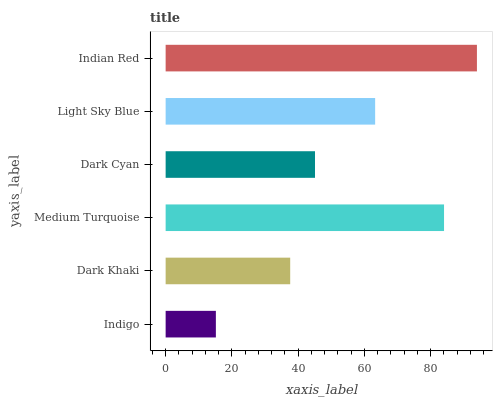Is Indigo the minimum?
Answer yes or no. Yes. Is Indian Red the maximum?
Answer yes or no. Yes. Is Dark Khaki the minimum?
Answer yes or no. No. Is Dark Khaki the maximum?
Answer yes or no. No. Is Dark Khaki greater than Indigo?
Answer yes or no. Yes. Is Indigo less than Dark Khaki?
Answer yes or no. Yes. Is Indigo greater than Dark Khaki?
Answer yes or no. No. Is Dark Khaki less than Indigo?
Answer yes or no. No. Is Light Sky Blue the high median?
Answer yes or no. Yes. Is Dark Cyan the low median?
Answer yes or no. Yes. Is Indian Red the high median?
Answer yes or no. No. Is Medium Turquoise the low median?
Answer yes or no. No. 